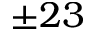<formula> <loc_0><loc_0><loc_500><loc_500>\pm 2 3</formula> 